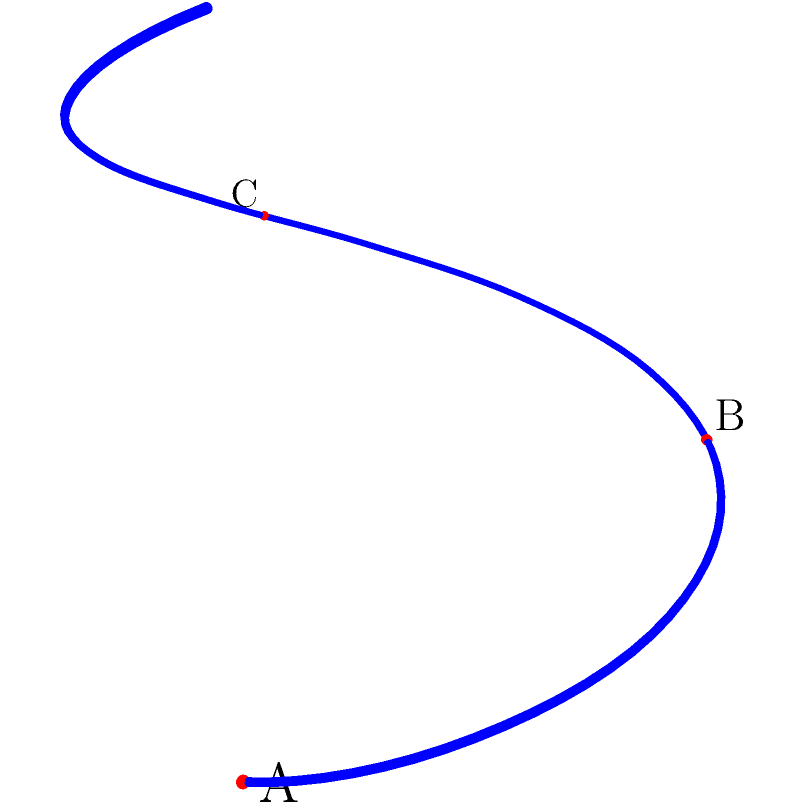Consider the DNA helix structure represented by the geometric spiral shown above. Points A, B, and C represent specific nucleotides along the helix. If we define a rotation operation R that moves each point to the next point clockwise (A → B → C → A), what is the order of the cyclic group generated by R, and how many distinct rotations are needed to return to the original configuration? To solve this problem, we need to analyze the cyclic group generated by the rotation operation R. Let's follow these steps:

1. Identify the group operation: The operation is the rotation R, which moves each point to the next clockwise position.

2. Determine the effect of repeated applications of R:
   R¹: A → B, B → C, C → A
   R²: A → C, B → A, C → B
   R³: A → A, B → B, C → C

3. Analyze the group structure:
   - R³ returns all points to their original positions.
   - This means that R³ is equivalent to the identity operation.

4. Determine the order of the group:
   - The order of a cyclic group is the smallest positive integer n such that R^n = identity.
   - In this case, R³ = identity, so the order of the group is 3.

5. Count distinct rotations:
   - The distinct rotations are R⁰ (identity), R¹, and R².
   - There are 3 distinct rotations before returning to the original configuration.

Therefore, the cyclic group generated by R has order 3, and it takes 3 distinct rotations to return to the original configuration.
Answer: Order: 3; Distinct rotations: 3 